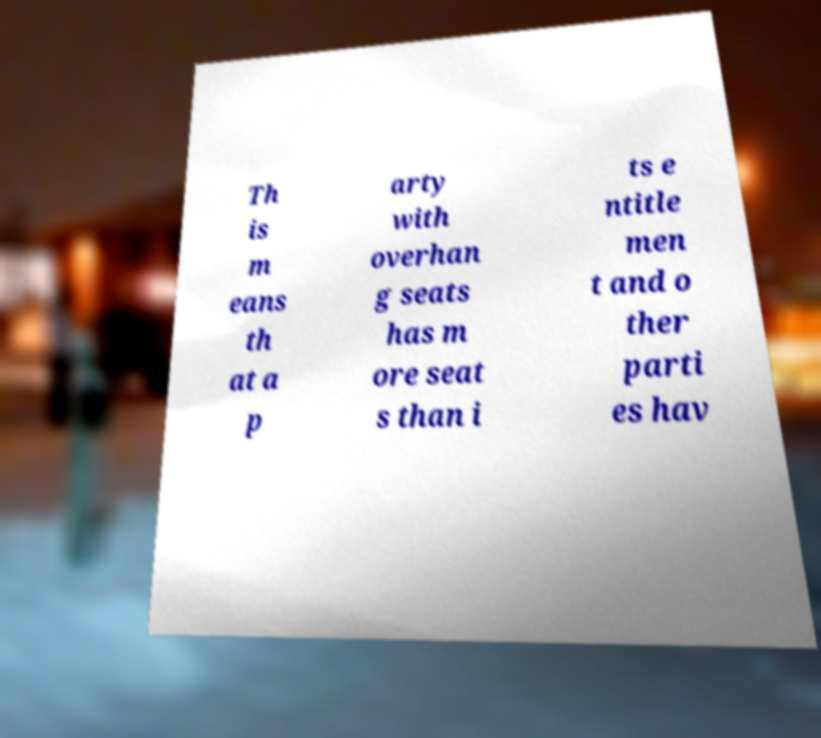Can you accurately transcribe the text from the provided image for me? Th is m eans th at a p arty with overhan g seats has m ore seat s than i ts e ntitle men t and o ther parti es hav 